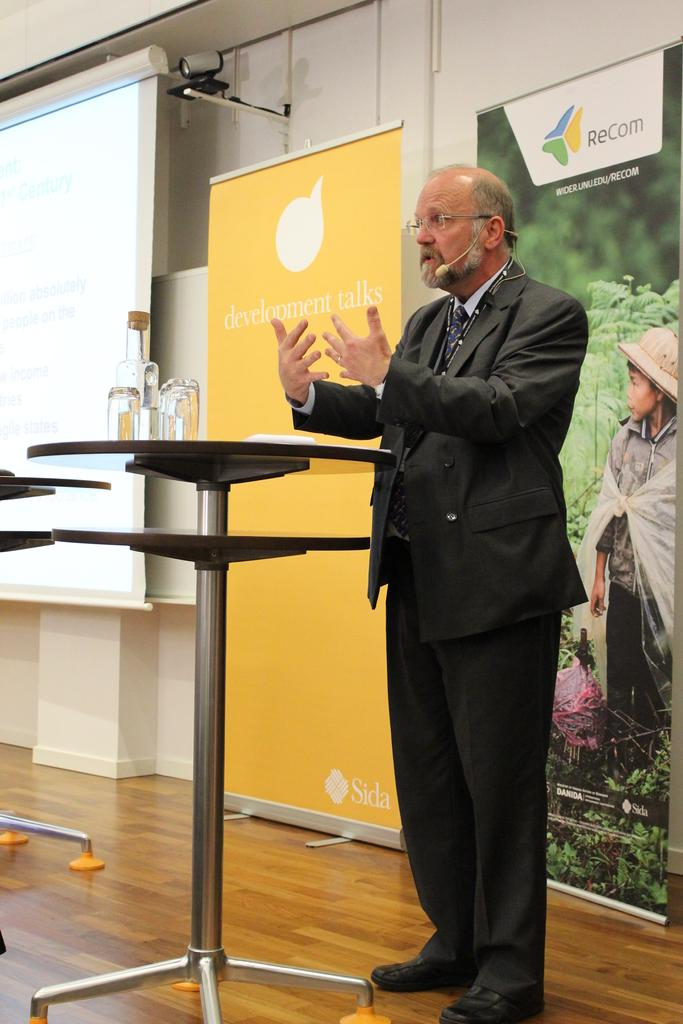What is the color of the wall in the image? The wall in the image is white. What device is present in the image for displaying information? There is a screen in the image. What type of security device is present in the image? A CCTV camera is present in the image. What additional signage is present in the image? There is a banner in the image. What is the man in the image wearing? The man in the image is wearing a mic. What is the man in the image doing? The man is standing in the image. Is there any snow visible on the ground in the image? There is no mention of snow or ground in the provided facts, so it cannot be determined if there is snow in the image. 